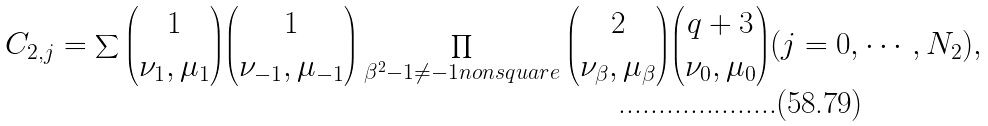Convert formula to latex. <formula><loc_0><loc_0><loc_500><loc_500>C _ { 2 , j } = \sum { \binom { 1 } { \nu _ { 1 } , \mu _ { 1 } } } { \binom { 1 } { \nu _ { - 1 } , \mu _ { - 1 } } } \prod _ { \beta ^ { 2 } - 1 \neq - 1 n o n s q u a r e } { \binom { 2 } { \nu _ { \beta } , \mu _ { \beta } } } { \binom { q + 3 } { \nu _ { 0 } , \mu _ { 0 } } } ( j = 0 , \cdots , N _ { 2 } ) ,</formula> 